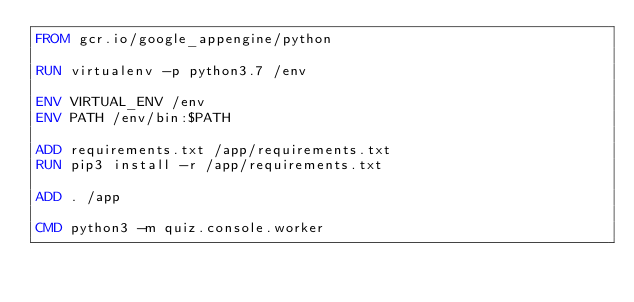Convert code to text. <code><loc_0><loc_0><loc_500><loc_500><_Dockerfile_>FROM gcr.io/google_appengine/python

RUN virtualenv -p python3.7 /env

ENV VIRTUAL_ENV /env
ENV PATH /env/bin:$PATH

ADD requirements.txt /app/requirements.txt
RUN pip3 install -r /app/requirements.txt

ADD . /app

CMD python3 -m quiz.console.worker
</code> 